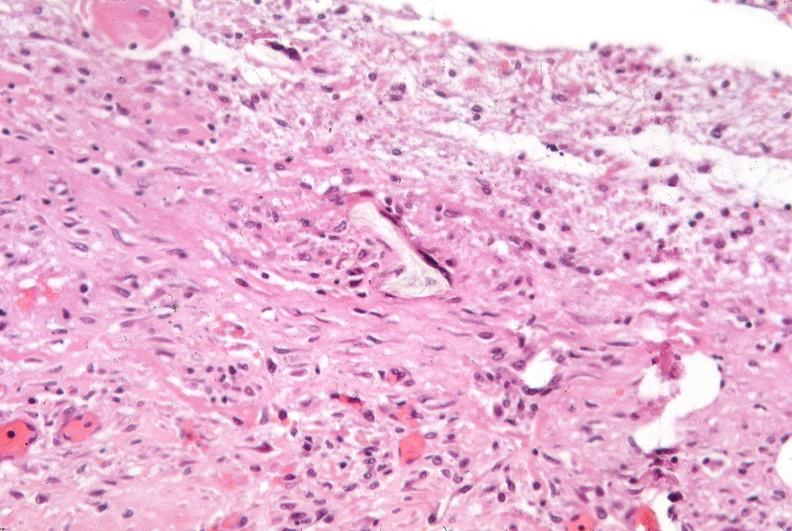s respiratory present?
Answer the question using a single word or phrase. Yes 